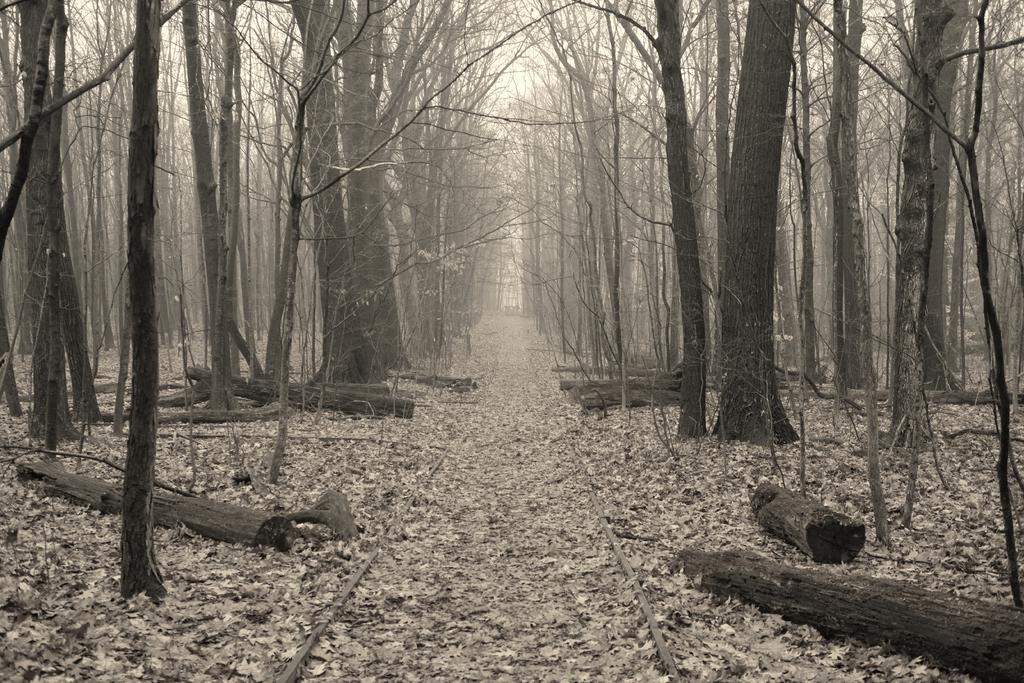In one or two sentences, can you explain what this image depicts? In this image, we can see so many trees. At the bottom of the image, we can see track, dry leaves and wooden logs. Background we can see the sky. 